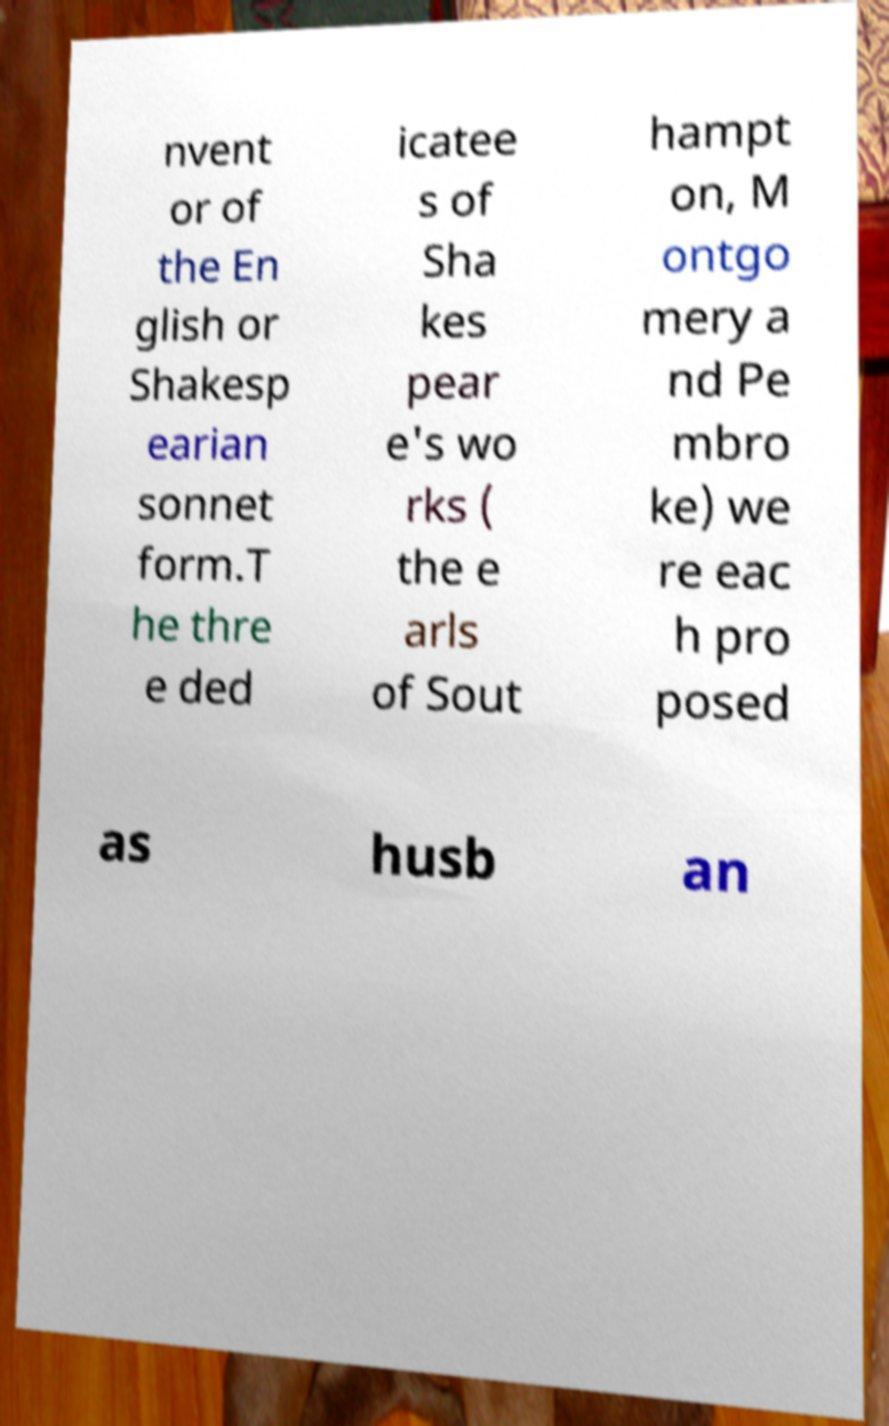Can you read and provide the text displayed in the image?This photo seems to have some interesting text. Can you extract and type it out for me? nvent or of the En glish or Shakesp earian sonnet form.T he thre e ded icatee s of Sha kes pear e's wo rks ( the e arls of Sout hampt on, M ontgo mery a nd Pe mbro ke) we re eac h pro posed as husb an 